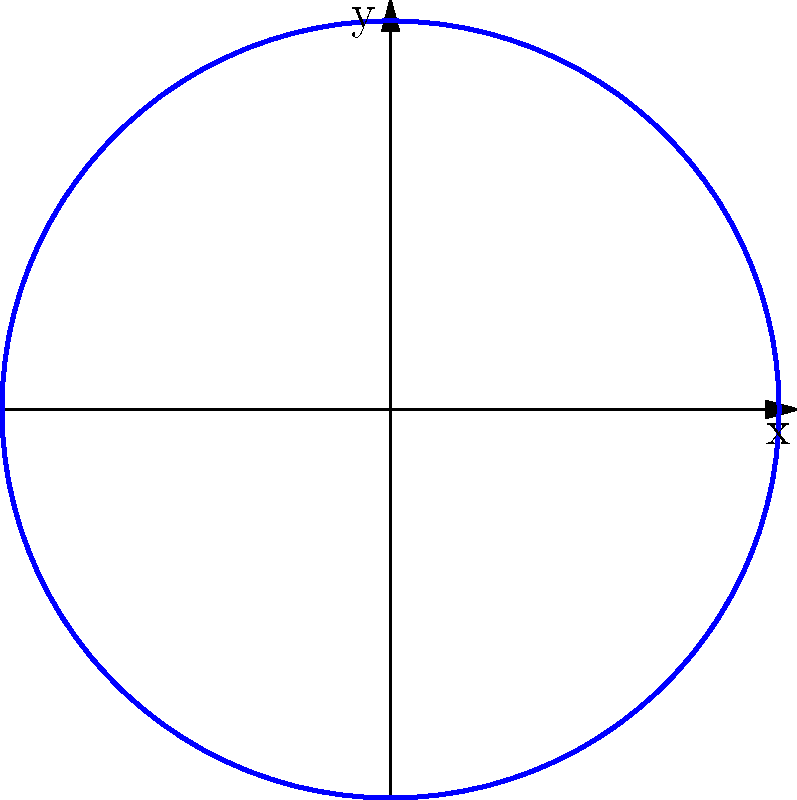As a digital artist translating radio frequencies into visual representations, you're working on a project that transforms sine waves into spiral patterns. Given the parametric equations $x = 2\sin(t)$ and $y = 2\cos(t)$, what is the equation of the resulting curve in Cartesian coordinates? Express your answer in terms of $x$ and $y$. Let's approach this step-by-step:

1) We start with the parametric equations:
   $x = 2\sin(t)$
   $y = 2\cos(t)$

2) To find the Cartesian equation, we need to eliminate the parameter $t$.

3) Let's square both equations:
   $x^2 = 4\sin^2(t)$
   $y^2 = 4\cos^2(t)$

4) Now, add these equations:
   $x^2 + y^2 = 4\sin^2(t) + 4\cos^2(t)$

5) Recall the trigonometric identity: $\sin^2(t) + \cos^2(t) = 1$

6) Applying this identity to our equation:
   $x^2 + y^2 = 4(\sin^2(t) + \cos^2(t)) = 4(1) = 4$

7) Therefore, the Cartesian equation of the curve is:
   $x^2 + y^2 = 4$

This is the equation of a circle with radius 2 centered at the origin.
Answer: $x^2 + y^2 = 4$ 